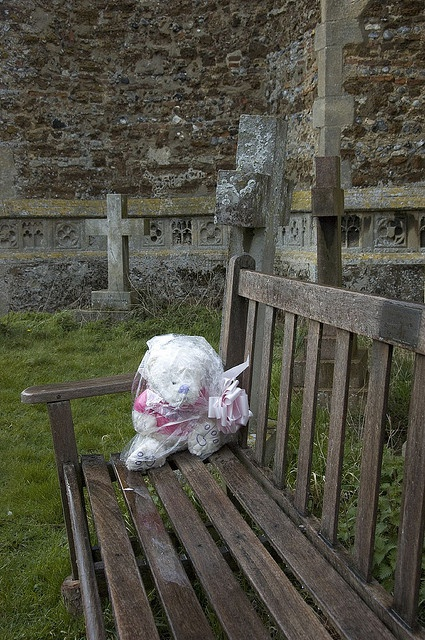Describe the objects in this image and their specific colors. I can see bench in gray, black, and darkgreen tones and teddy bear in gray, lightgray, and darkgray tones in this image. 